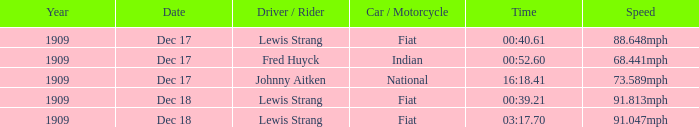What vehicle/motorcycle can attain 9 Fiat. 